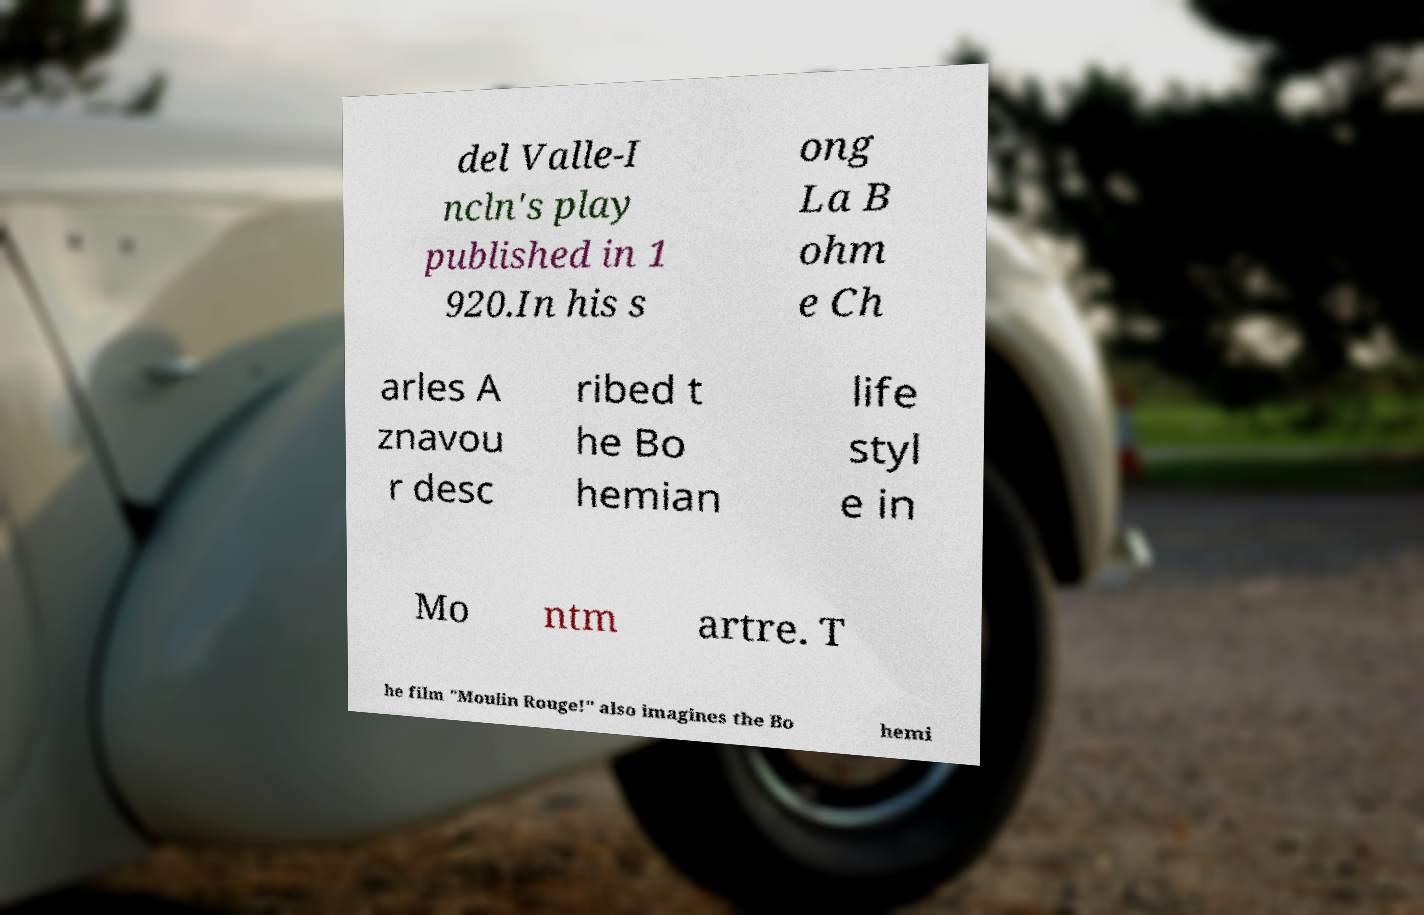Can you read and provide the text displayed in the image?This photo seems to have some interesting text. Can you extract and type it out for me? del Valle-I ncln's play published in 1 920.In his s ong La B ohm e Ch arles A znavou r desc ribed t he Bo hemian life styl e in Mo ntm artre. T he film "Moulin Rouge!" also imagines the Bo hemi 